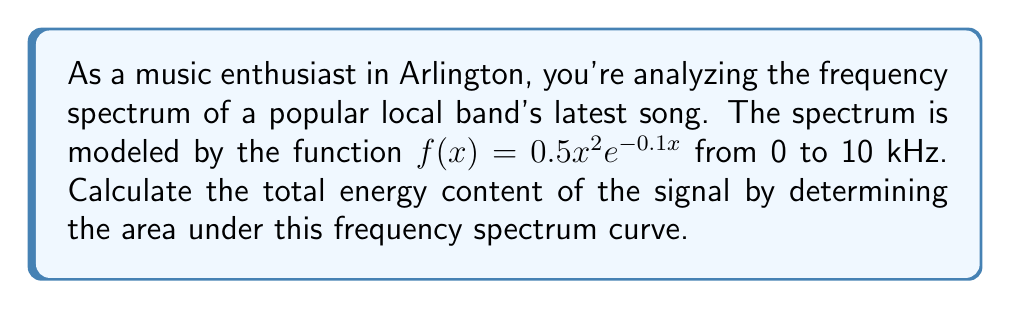Teach me how to tackle this problem. To find the area under the curve, we need to integrate the function $f(x) = 0.5x^2e^{-0.1x}$ from 0 to 10 kHz. Let's approach this step-by-step:

1) Set up the definite integral:
   $$\int_0^{10} 0.5x^2e^{-0.1x} dx$$

2) This integral doesn't have an elementary antiderivative, so we'll need to use integration by parts twice. Let $u = x^2$ and $dv = e^{-0.1x}dx$.

3) First integration by parts:
   $$\int x^2e^{-0.1x} dx = -10x^2e^{-0.1x} + \int 20xe^{-0.1x} dx$$

4) Second integration by parts (let $u = x$ and $dv = e^{-0.1x}dx$):
   $$-10x^2e^{-0.1x} + (-200xe^{-0.1x} + \int 200e^{-0.1x} dx)$$

5) Simplify:
   $$-10x^2e^{-0.1x} - 200xe^{-0.1x} - 2000e^{-0.1x} + C$$

6) Now, apply the limits of integration:
   $$[-10x^2e^{-0.1x} - 200xe^{-0.1x} - 2000e^{-0.1x}]_0^{10}$$

7) Evaluate at x = 10:
   $$-10(10^2)e^{-1} - 200(10)e^{-1} - 2000e^{-1}$$

8) Evaluate at x = 0:
   $$-10(0^2)e^{0} - 200(0)e^{0} - 2000e^{0} = -2000$$

9) Subtract the results:
   $$(-1000e^{-1} - 2000e^{-1} - 2000e^{-1}) - (-2000) = 2000 - 5000e^{-1}$$

10) Multiply the result by 0.5 (from the original function):
    $$0.5(2000 - 5000e^{-1}) = 1000 - 2500e^{-1}$$
Answer: The area under the frequency spectrum curve is $1000 - 2500e^{-1}$ ≈ 79.45 (energy units). 